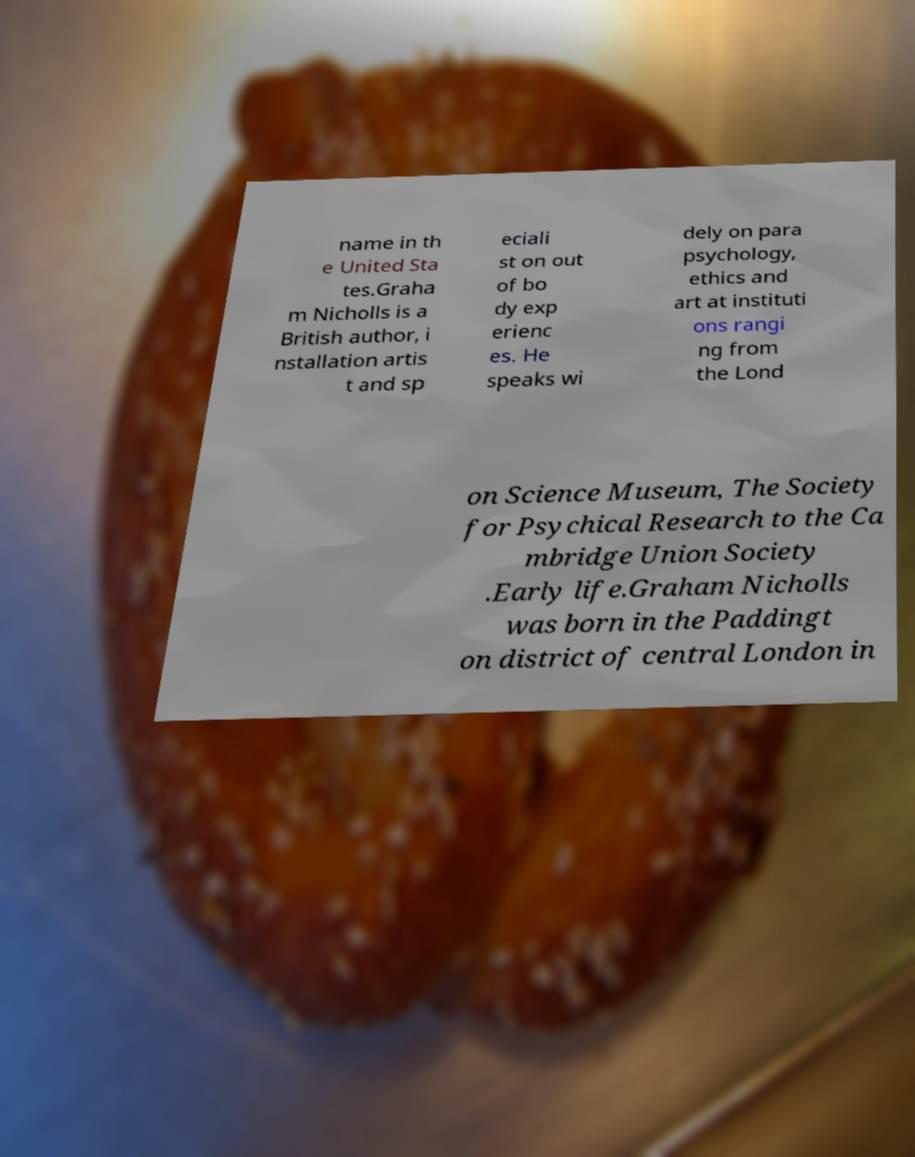There's text embedded in this image that I need extracted. Can you transcribe it verbatim? name in th e United Sta tes.Graha m Nicholls is a British author, i nstallation artis t and sp eciali st on out of bo dy exp erienc es. He speaks wi dely on para psychology, ethics and art at instituti ons rangi ng from the Lond on Science Museum, The Society for Psychical Research to the Ca mbridge Union Society .Early life.Graham Nicholls was born in the Paddingt on district of central London in 